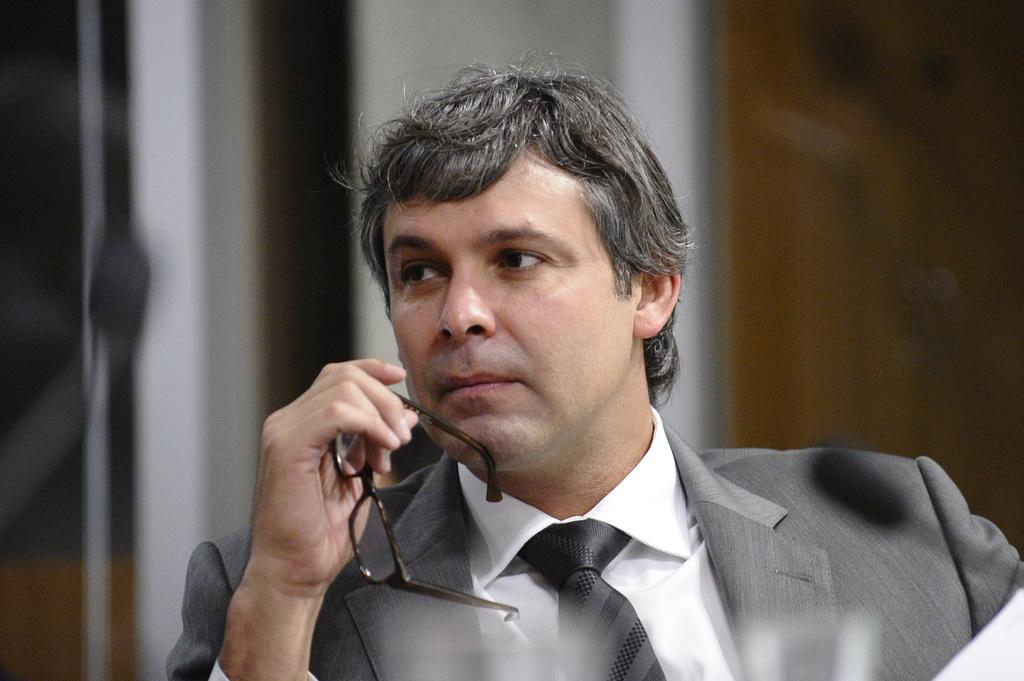What is the main subject of the image? There is a man in the image. What is the man holding in the image? The man is holding a spectacle. Can you describe the background of the image? There may be a wall behind the man. What type of jam is the man spreading on his toes in the image? There is no jam or toes present in the image; the man is holding a spectacle. 